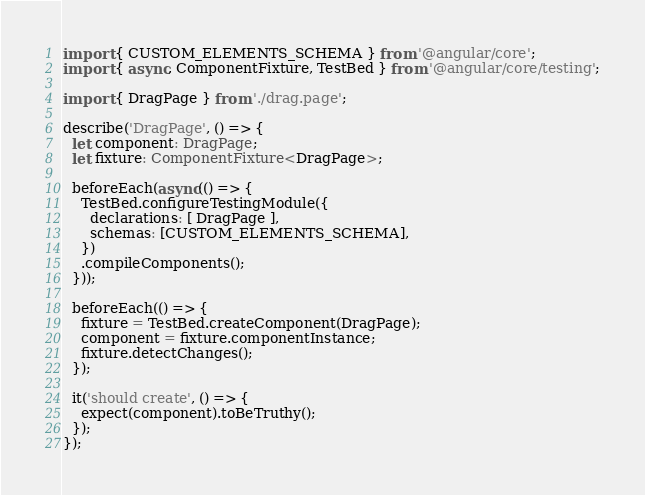<code> <loc_0><loc_0><loc_500><loc_500><_TypeScript_>import { CUSTOM_ELEMENTS_SCHEMA } from '@angular/core';
import { async, ComponentFixture, TestBed } from '@angular/core/testing';

import { DragPage } from './drag.page';

describe('DragPage', () => {
  let component: DragPage;
  let fixture: ComponentFixture<DragPage>;

  beforeEach(async(() => {
    TestBed.configureTestingModule({
      declarations: [ DragPage ],
      schemas: [CUSTOM_ELEMENTS_SCHEMA],
    })
    .compileComponents();
  }));

  beforeEach(() => {
    fixture = TestBed.createComponent(DragPage);
    component = fixture.componentInstance;
    fixture.detectChanges();
  });

  it('should create', () => {
    expect(component).toBeTruthy();
  });
});
</code> 